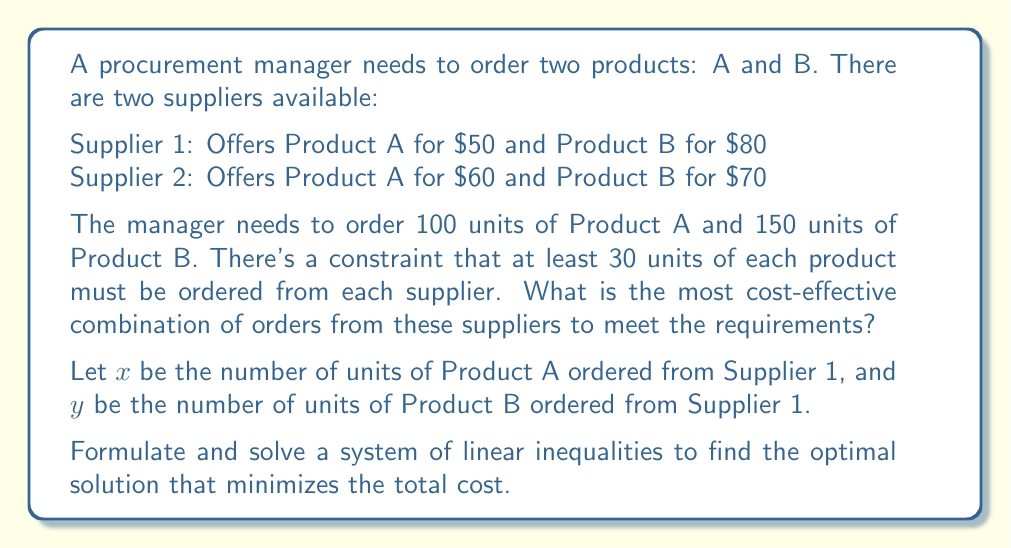Help me with this question. Let's approach this step-by-step:

1) First, let's define our variables:
   $x$ = units of Product A from Supplier 1
   $y$ = units of Product B from Supplier 1

2) We can express the units from Supplier 2 as:
   Product A from Supplier 2: $100 - x$
   Product B from Supplier 2: $150 - y$

3) Now, let's set up our constraints:
   $x \geq 30$ (at least 30 units of A from Supplier 1)
   $y \geq 30$ (at least 30 units of B from Supplier 1)
   $100 - x \geq 30$ (at least 30 units of A from Supplier 2)
   $150 - y \geq 30$ (at least 30 units of B from Supplier 2)

4) Simplify the last two inequalities:
   $x \leq 70$
   $y \leq 120$

5) Our objective function (total cost) is:
   $C = 50x + 80y + 60(100-x) + 70(150-y)$
   
   Simplify:
   $C = 50x + 80y + 6000 - 60x + 10500 - 70y$
   $C = -10x + 10y + 16500$

6) We want to minimize C. Since the coefficient of x is negative and the coefficient of y is positive, we should maximize x and minimize y within our constraints.

7) The optimal solution will be:
   $x = 70$ (maximum possible)
   $y = 30$ (minimum possible)

8) Calculate the total cost:
   $C = -10(70) + 10(30) + 16500 = 16100$

9) The order breakdown:
   From Supplier 1: 70 units of A, 30 units of B
   From Supplier 2: 30 units of A, 120 units of B
Answer: Order 70 units of A and 30 units of B from Supplier 1, and 30 units of A and 120 units of B from Supplier 2. Total cost: $16,100. 